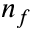Convert formula to latex. <formula><loc_0><loc_0><loc_500><loc_500>n _ { f }</formula> 